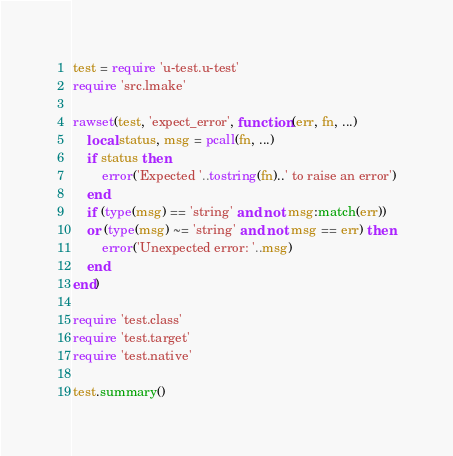Convert code to text. <code><loc_0><loc_0><loc_500><loc_500><_Lua_>test = require 'u-test.u-test'
require 'src.lmake'

rawset(test, 'expect_error', function (err, fn, ...)
    local status, msg = pcall(fn, ...)
    if status then
        error('Expected '..tostring(fn)..' to raise an error')
    end
    if (type(msg) == 'string' and not msg:match(err))
    or (type(msg) ~= 'string' and not msg == err) then
        error('Unexpected error: '..msg)
    end
end)

require 'test.class'
require 'test.target'
require 'test.native'

test.summary()
</code> 